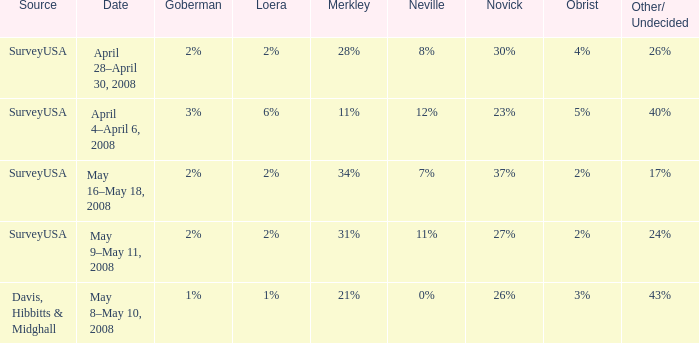Which Novick has a Source of surveyusa, and a Neville of 8%? 30%. 